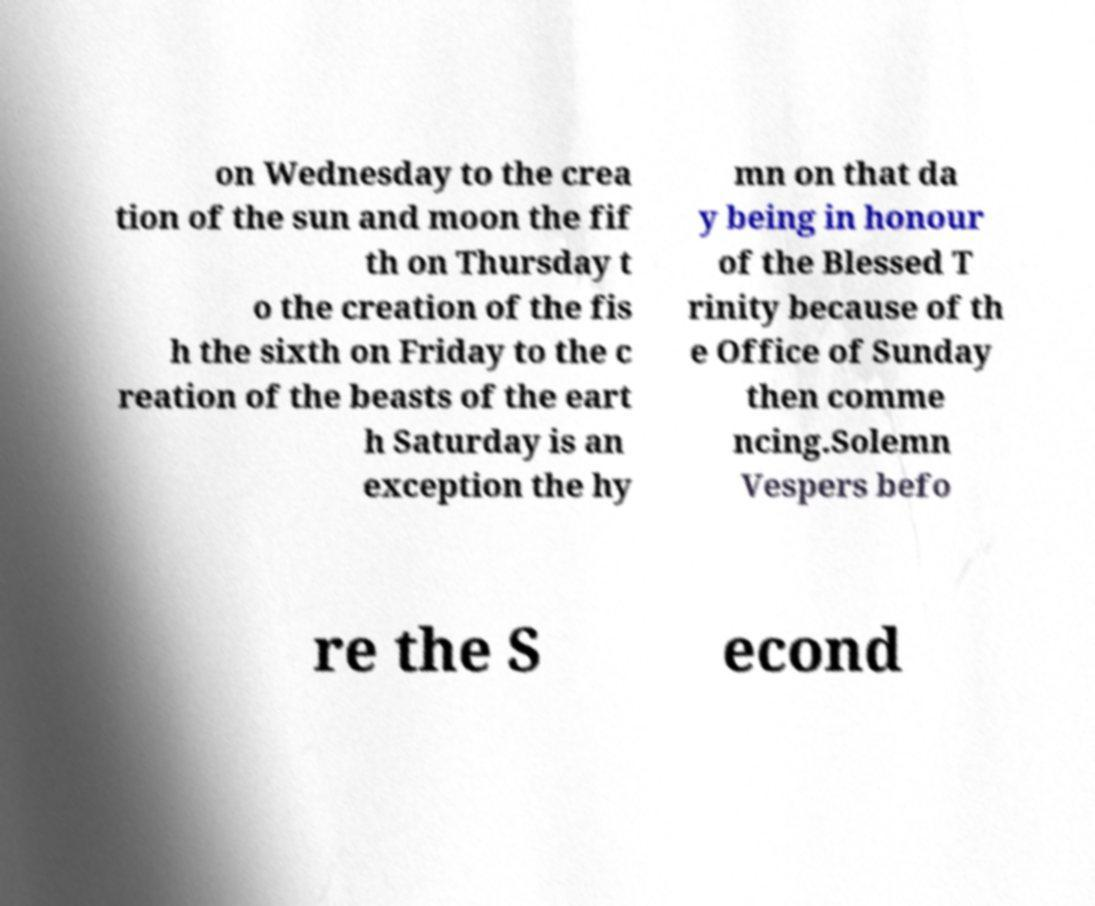For documentation purposes, I need the text within this image transcribed. Could you provide that? on Wednesday to the crea tion of the sun and moon the fif th on Thursday t o the creation of the fis h the sixth on Friday to the c reation of the beasts of the eart h Saturday is an exception the hy mn on that da y being in honour of the Blessed T rinity because of th e Office of Sunday then comme ncing.Solemn Vespers befo re the S econd 